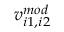<formula> <loc_0><loc_0><loc_500><loc_500>v _ { i 1 , i 2 } ^ { m o d }</formula> 